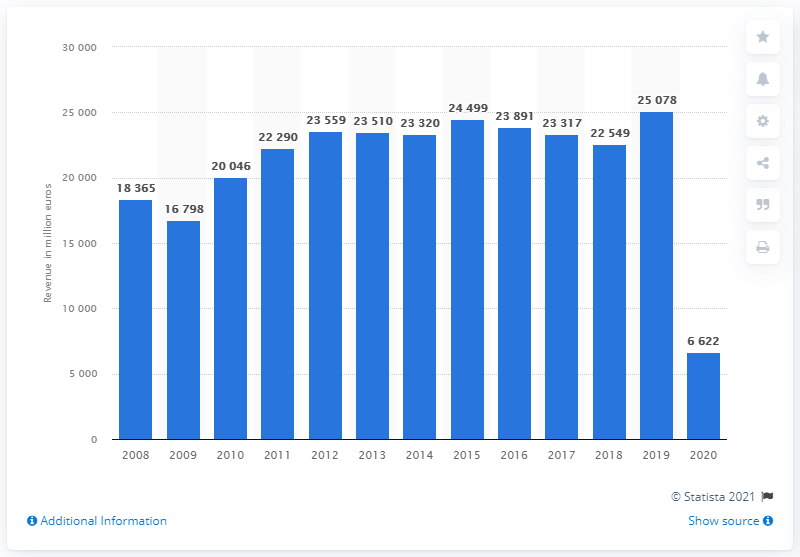Outline some significant characteristics in this image. Lufthansa's network airlines generated revenue of approximately 6,622 in the fiscal year of 2020. In the year 2008, the network airlines segment of Lufthansa generated revenue. 